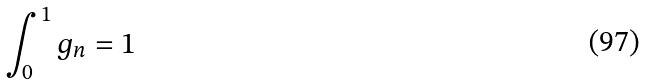Convert formula to latex. <formula><loc_0><loc_0><loc_500><loc_500>\int _ { 0 } ^ { 1 } g _ { n } = 1</formula> 